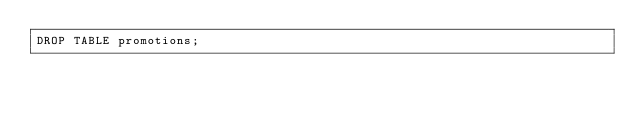<code> <loc_0><loc_0><loc_500><loc_500><_SQL_>DROP TABLE promotions;</code> 